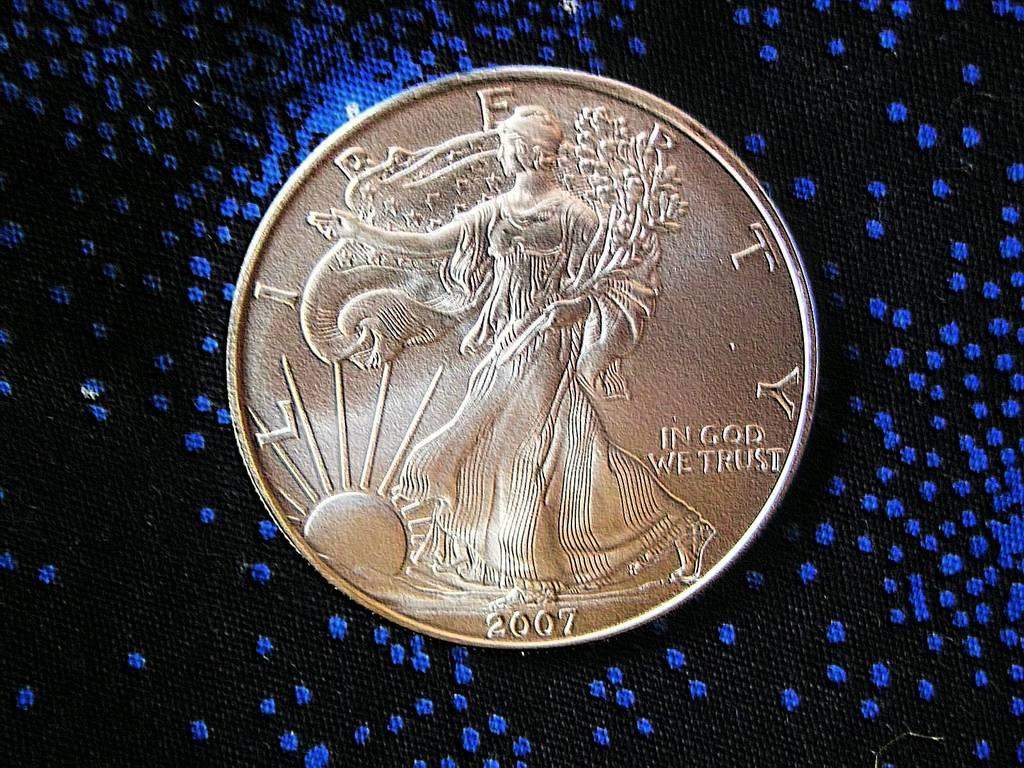<image>
Create a compact narrative representing the image presented. A silver coin from 2007 is against a black and blue background. 